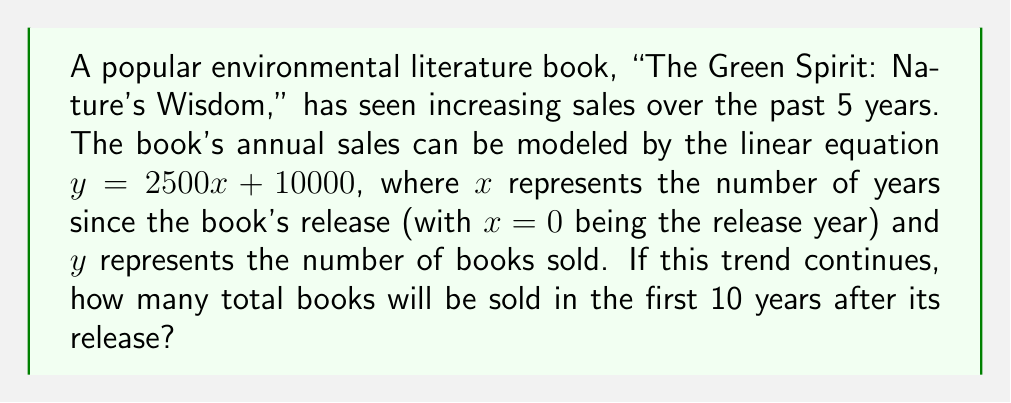Could you help me with this problem? To solve this problem, we need to follow these steps:

1) First, let's understand what the equation $y = 2500x + 10000$ means:
   - $y$ is the number of books sold in a given year
   - $x$ is the number of years since the book's release
   - 2500 is the annual increase in sales
   - 10000 is the initial number of books sold in the release year

2) To find the total number of books sold over 10 years, we need to calculate the sum of sales for each year from year 0 to year 9 (which gives us 10 years in total).

3) We can do this by substituting $x$ values from 0 to 9 into our equation:

   Year 0: $y = 2500(0) + 10000 = 10000$
   Year 1: $y = 2500(1) + 10000 = 12500$
   Year 2: $y = 2500(2) + 10000 = 15000$
   ...
   Year 9: $y = 2500(9) + 10000 = 32500$

4) However, instead of calculating each year individually, we can use the formula for the sum of an arithmetic sequence:

   $S_n = \frac{n(a_1 + a_n)}{2}$

   Where:
   $S_n$ is the sum of the sequence
   $n$ is the number of terms (in this case, 10)
   $a_1$ is the first term (10000)
   $a_n$ is the last term (32500)

5) Plugging in our values:

   $S_{10} = \frac{10(10000 + 32500)}{2}$

6) Simplifying:

   $S_{10} = \frac{10(42500)}{2} = \frac{425000}{2} = 212500$

Therefore, the total number of books sold in the first 10 years after its release will be 212,500.
Answer: 212,500 books 